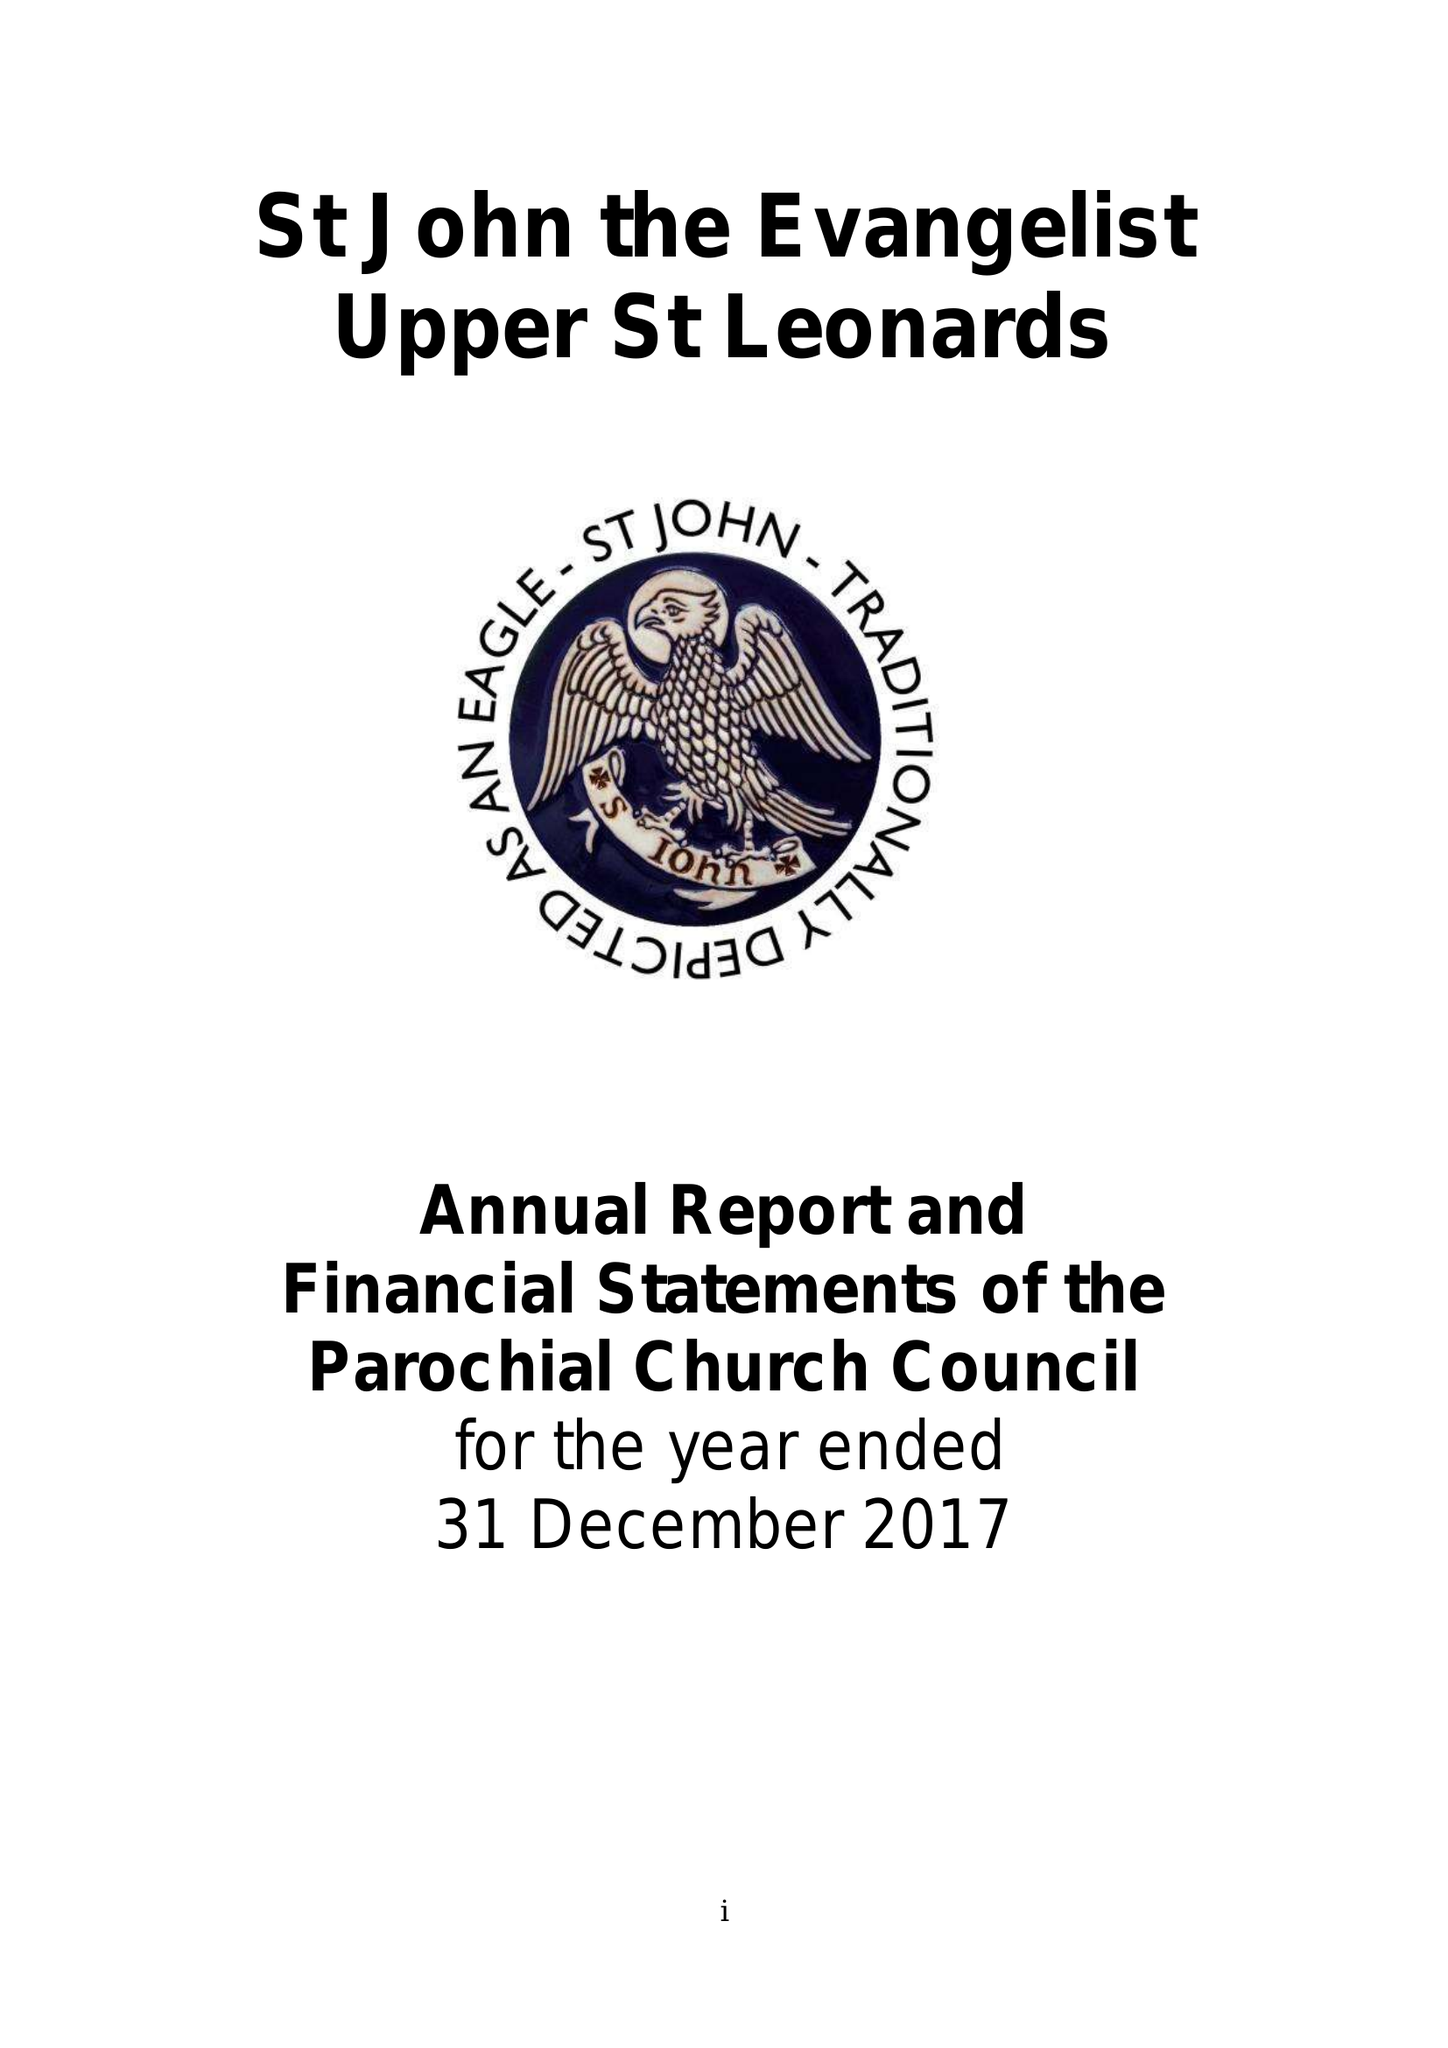What is the value for the charity_number?
Answer the question using a single word or phrase. 1132339 